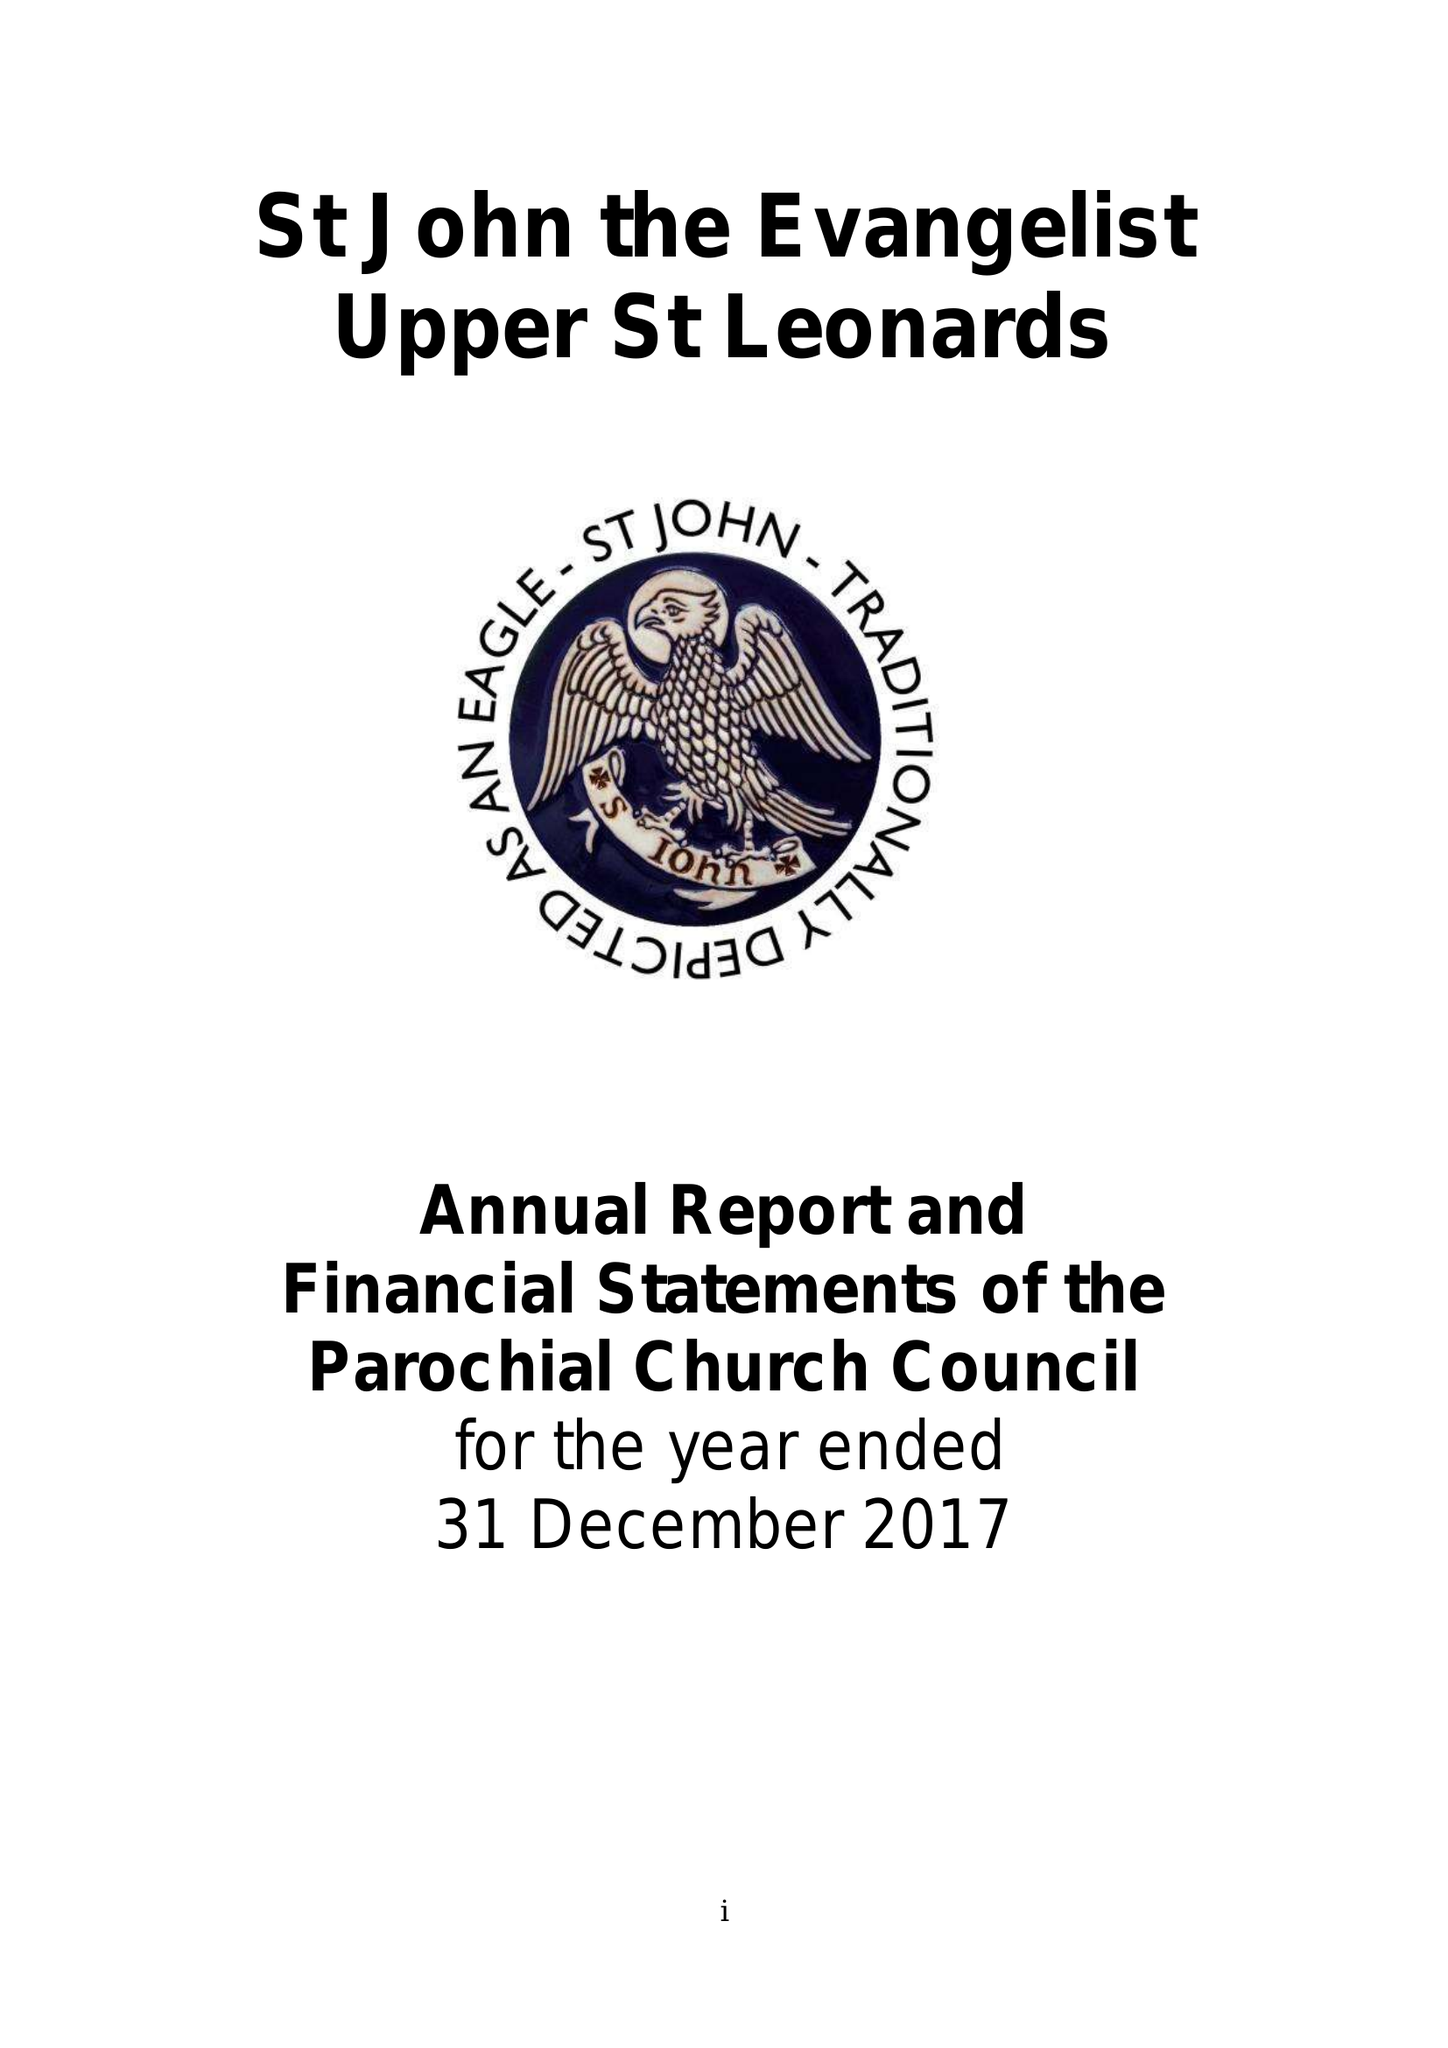What is the value for the charity_number?
Answer the question using a single word or phrase. 1132339 